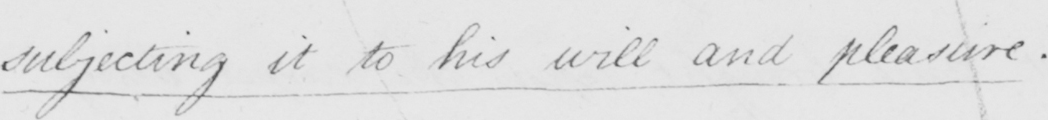What text is written in this handwritten line? subjecting it to his will and pleasure . 